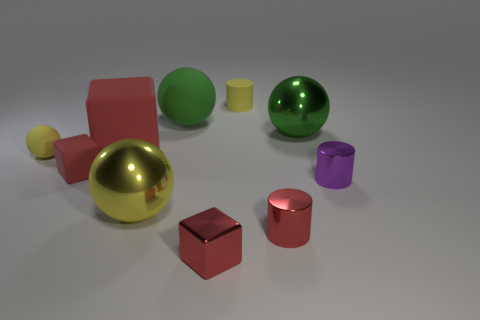How many yellow balls must be subtracted to get 1 yellow balls? 1 Subtract all big rubber balls. How many balls are left? 3 Subtract 1 cylinders. How many cylinders are left? 2 Subtract all red cylinders. How many cylinders are left? 2 Subtract all purple blocks. How many cyan cylinders are left? 0 Subtract all tiny gray shiny spheres. Subtract all rubber blocks. How many objects are left? 8 Add 1 red blocks. How many red blocks are left? 4 Add 5 yellow shiny objects. How many yellow shiny objects exist? 6 Subtract 0 yellow cubes. How many objects are left? 10 Subtract all balls. How many objects are left? 6 